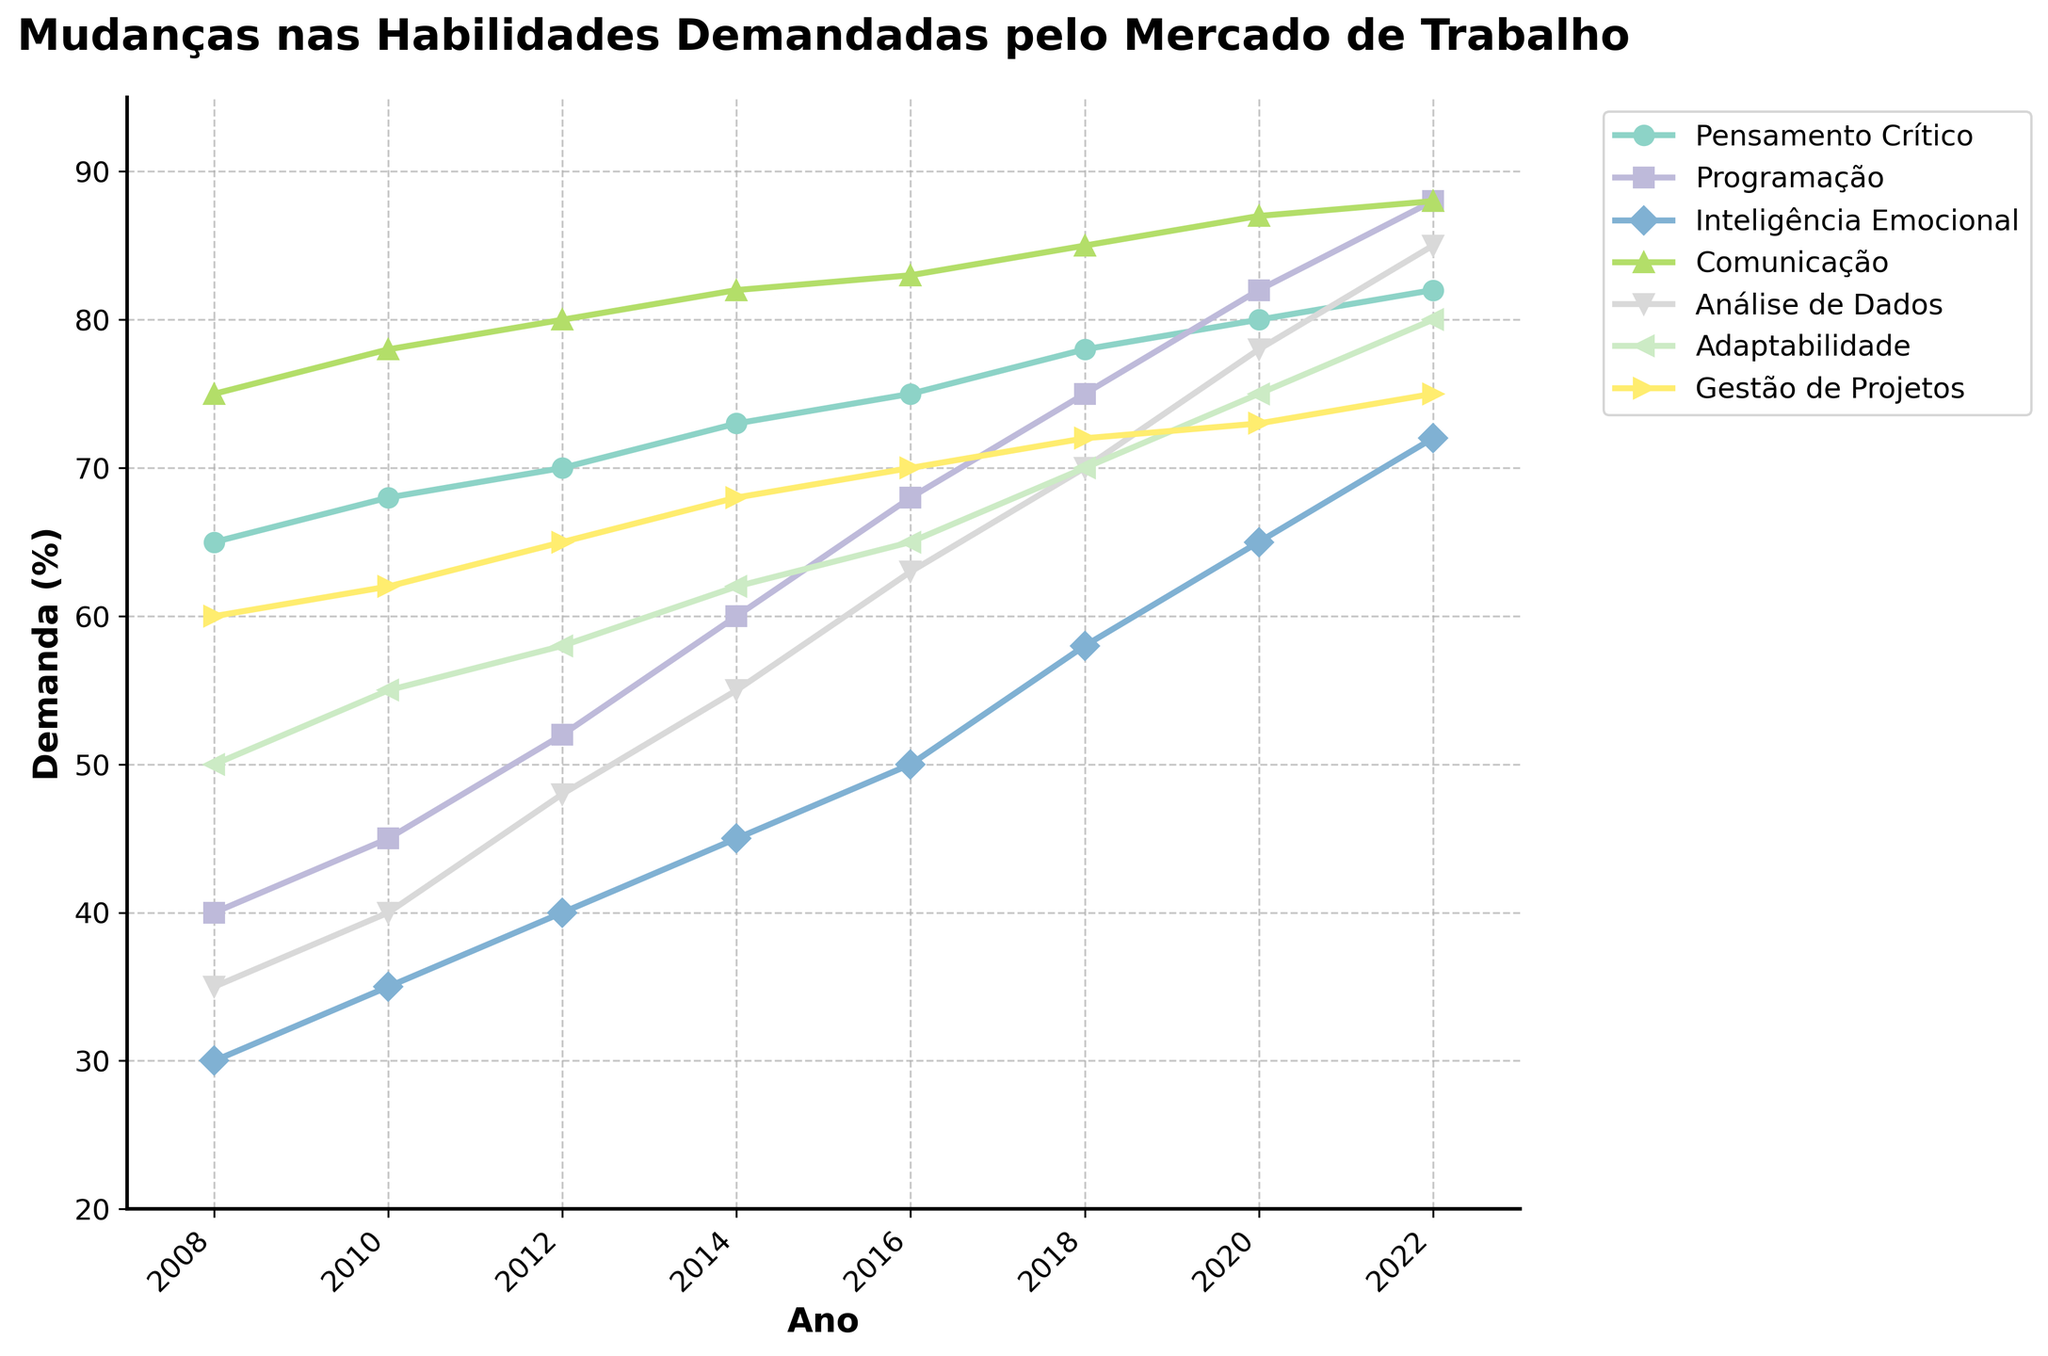Qual habilidade exibiu o maior aumento percentual na demanda ao longo dos últimos 15 anos? Observando a linha mais íngreme na figura, "Programação" teve o maior aumento percentual. Ela passou de 40% em 2008 para 88% em 2022, aumentando 48%.
Answer: Programação Qual foi a demanda de Inteligência Emocional em 2014? Observe o ponto correspondente ao ano de 2014 na linha que representa "Inteligência Emocional." O ponto está em 45%.
Answer: 45% Em que ano a demanda por Pensamento Crítico ultrapassou 75%? A linha de "Pensamento Crítico" ultrapassa 75% entre 2016 e 2018. O primeiro ano em que isso ocorre é 2018.
Answer: 2018 Como a demanda por Comunicação mudou de 2016 a 2022? Compare os pontos correspondentes aos anos de 2016 e 2022 na linha que representa "Comunicação." Em 2016, a demanda era de 83%, e em 2022, era 88%. Assim, houve um aumento de 5%.
Answer: Aumentou em 5% Quais habilidades estavam em maior demanda em 2020? Analise os pontos para 2020. As habilidades com maiores valores são "Comunicação" (87%) e "Pensamento Crítico" (80%).
Answer: Comunicação, Pensamento Crítico Qual foi a diferença na demanda por Gestão de Projetos entre 2008 e 2012? Subtraia o valor de 2008 (60%) do valor de 2012 (65%) para obter a diferença. A diferença é de 5%.
Answer: 5% A demanda por Análise de Dados cresceu consistentemente ao longo dos anos? Examine a linha de "Análise de Dados." A linha mostra um crescimento contínuo de 35% em 2008 para 85% em 2022.
Answer: Sim Entre 2018 e 2020, qual habilidade teve o maior crescimento percentual? Calcule a diferença para cada habilidade entre 2018 e 2020. "Programação" teve o maior crescimento, de 75% para 82%, um aumento de 7%.
Answer: Programação Como a demanda por Adaptabilidade mudou de 2008 a 2022? Compare os pontos de 2008 (50%) e 2022 (80%) na linha para "Adaptabilidade." A demanda aumentou em 30%.
Answer: Aumentou em 30% Qual cor representa a habilidade de Comunicação no gráfico? Observe a legenda do gráfico, onde cada habilidade é representada por uma cor específica. "Comunicação" é mostrada em azul.
Answer: Azul 